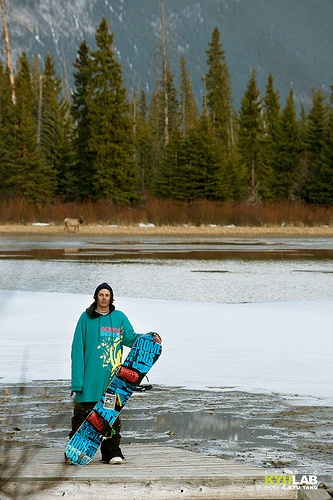Describe the objects in this image and their specific colors. I can see people in gray, black, teal, and white tones and snowboard in gray, black, lightblue, and teal tones in this image. 